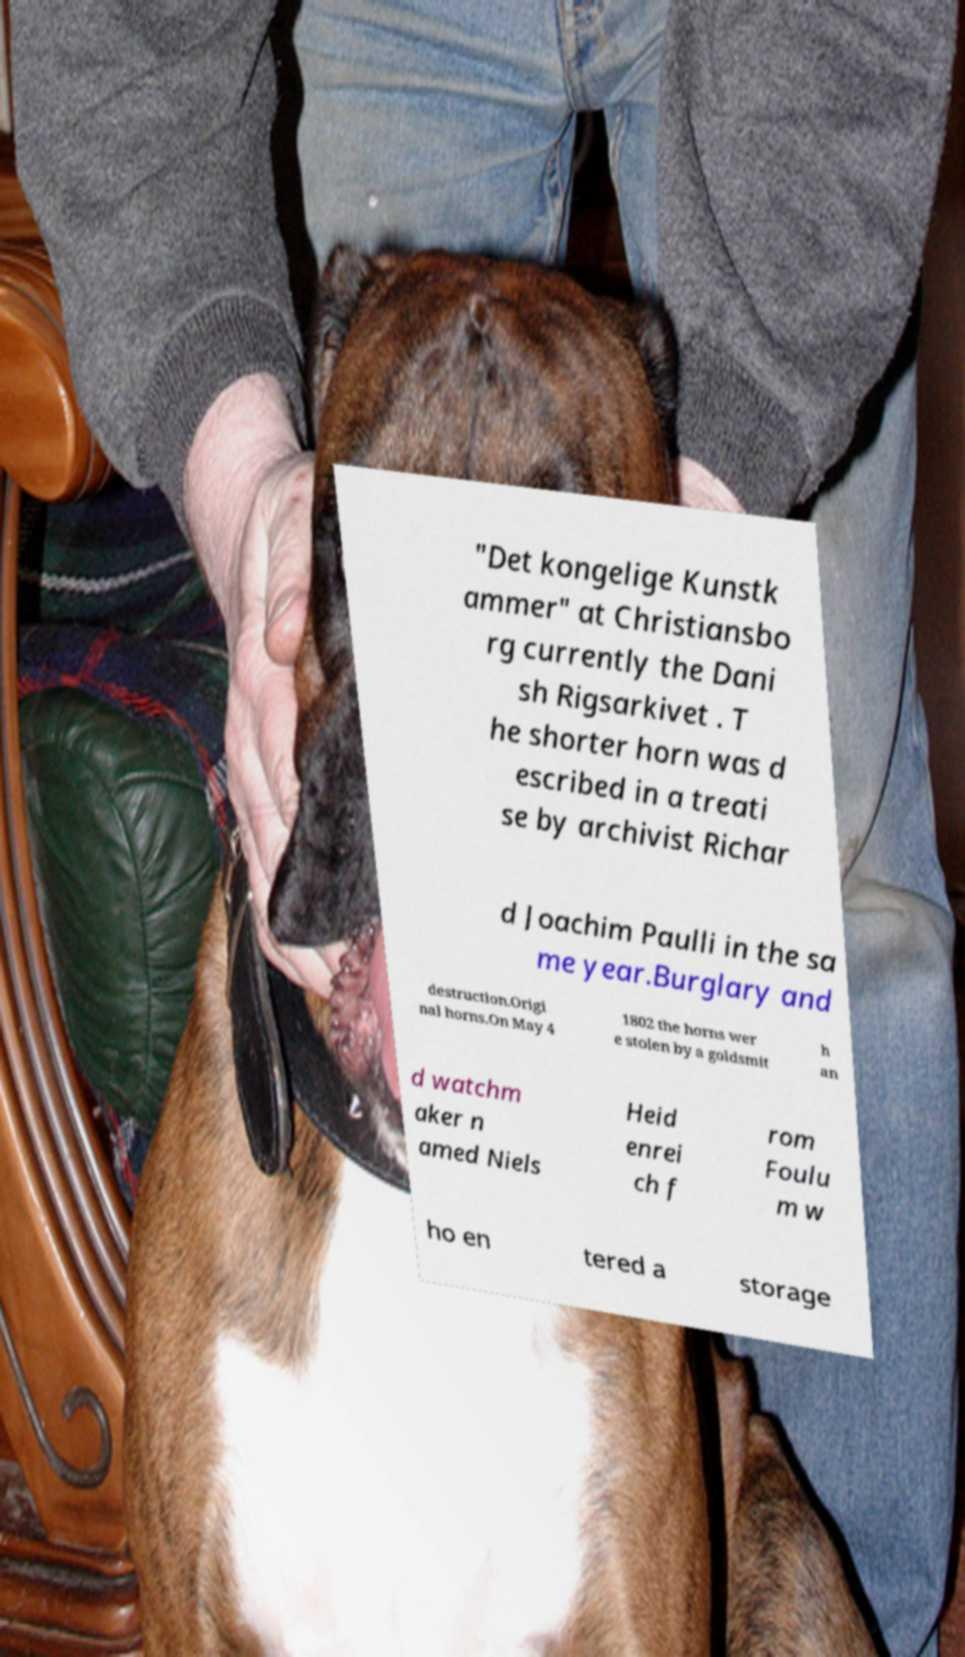There's text embedded in this image that I need extracted. Can you transcribe it verbatim? "Det kongelige Kunstk ammer" at Christiansbo rg currently the Dani sh Rigsarkivet . T he shorter horn was d escribed in a treati se by archivist Richar d Joachim Paulli in the sa me year.Burglary and destruction.Origi nal horns.On May 4 1802 the horns wer e stolen by a goldsmit h an d watchm aker n amed Niels Heid enrei ch f rom Foulu m w ho en tered a storage 